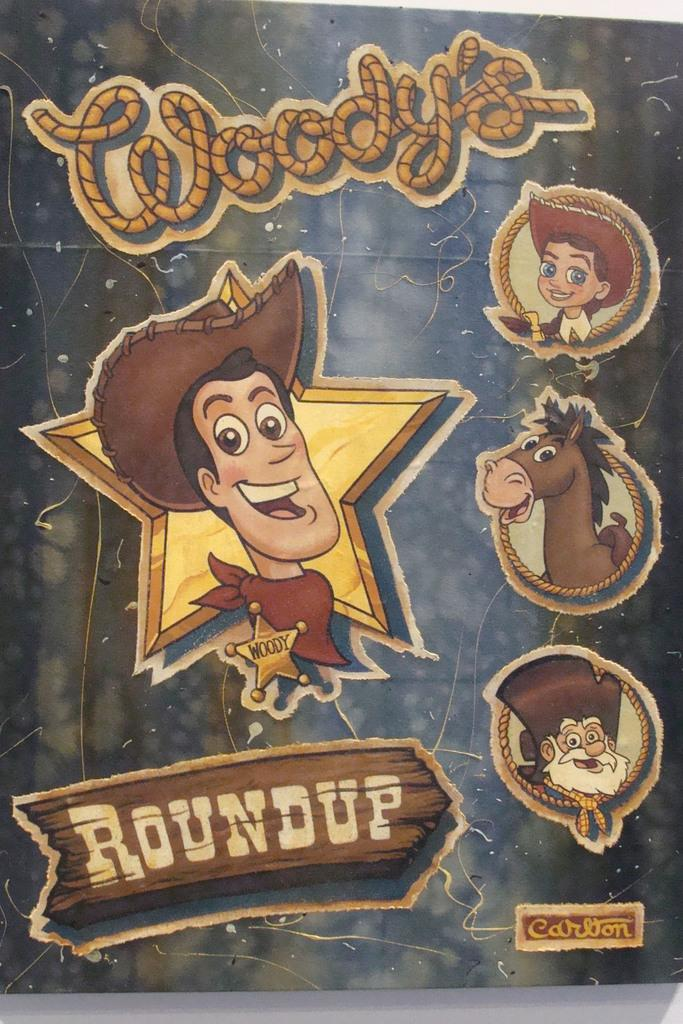What is present in the image that features text or images? There is a poster in the image. What colors are used in the poster? The poster has brown, cream, and black colors. What types of subjects are depicted on the poster? There is a person and an animal depicted on the poster. Who are the specific individuals depicted on the poster? There is a boy and a person with a white beard depicted on the poster. What type of soap is being advertised on the poster? There is no soap present on the poster; it features a boy, a person with a white beard, an animal, and uses brown, cream, and black colors. 